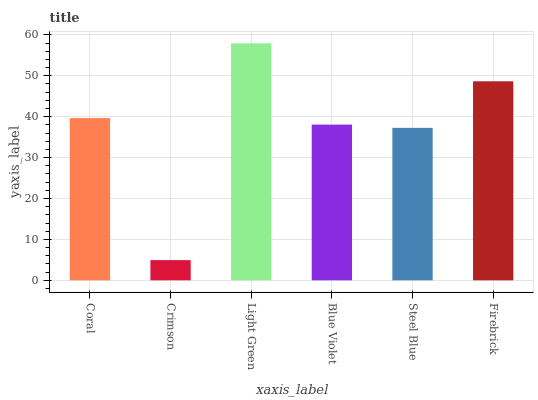Is Crimson the minimum?
Answer yes or no. Yes. Is Light Green the maximum?
Answer yes or no. Yes. Is Light Green the minimum?
Answer yes or no. No. Is Crimson the maximum?
Answer yes or no. No. Is Light Green greater than Crimson?
Answer yes or no. Yes. Is Crimson less than Light Green?
Answer yes or no. Yes. Is Crimson greater than Light Green?
Answer yes or no. No. Is Light Green less than Crimson?
Answer yes or no. No. Is Coral the high median?
Answer yes or no. Yes. Is Blue Violet the low median?
Answer yes or no. Yes. Is Blue Violet the high median?
Answer yes or no. No. Is Coral the low median?
Answer yes or no. No. 